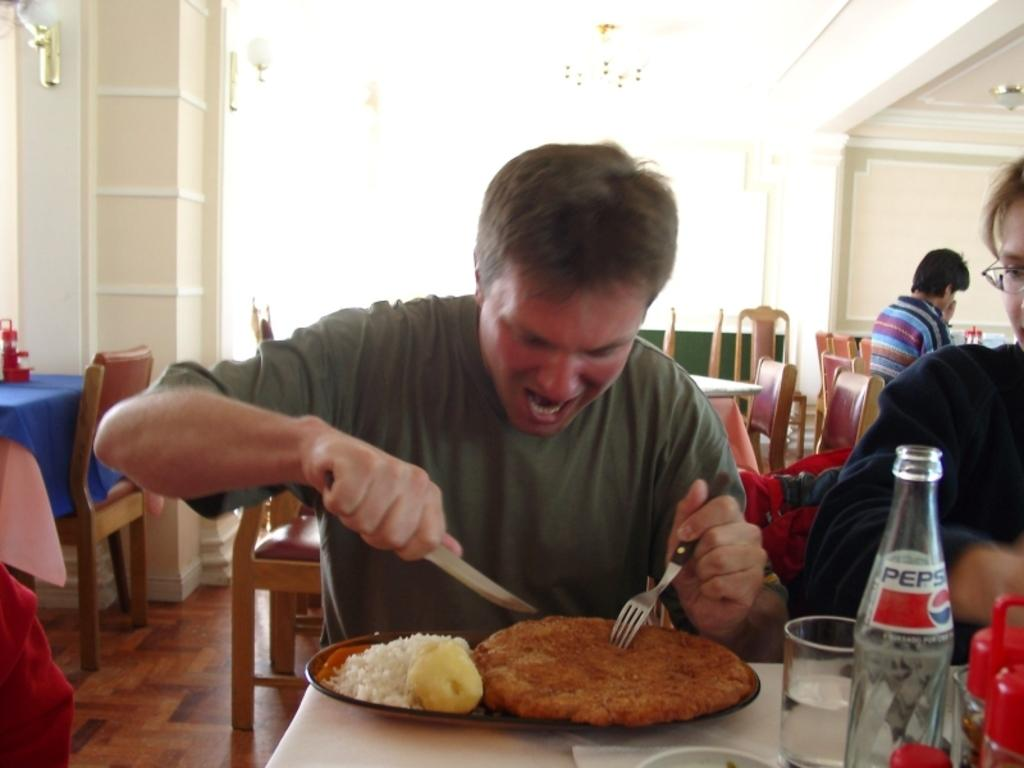What are the people in the image doing? The people in the image are sitting. Where are the people sitting in relation to the table? The people are sitting in front of the table. What can be seen on the table in the image? There is a plate with food and a bottle on the table. What else might be used for drinking on the table? There is a glass on the table. What type of milk is being transported in the image? There is no milk or transportation depicted in the image. 